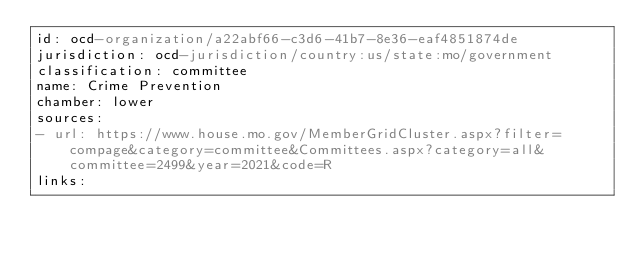<code> <loc_0><loc_0><loc_500><loc_500><_YAML_>id: ocd-organization/a22abf66-c3d6-41b7-8e36-eaf4851874de
jurisdiction: ocd-jurisdiction/country:us/state:mo/government
classification: committee
name: Crime Prevention
chamber: lower
sources:
- url: https://www.house.mo.gov/MemberGridCluster.aspx?filter=compage&category=committee&Committees.aspx?category=all&committee=2499&year=2021&code=R
links:</code> 